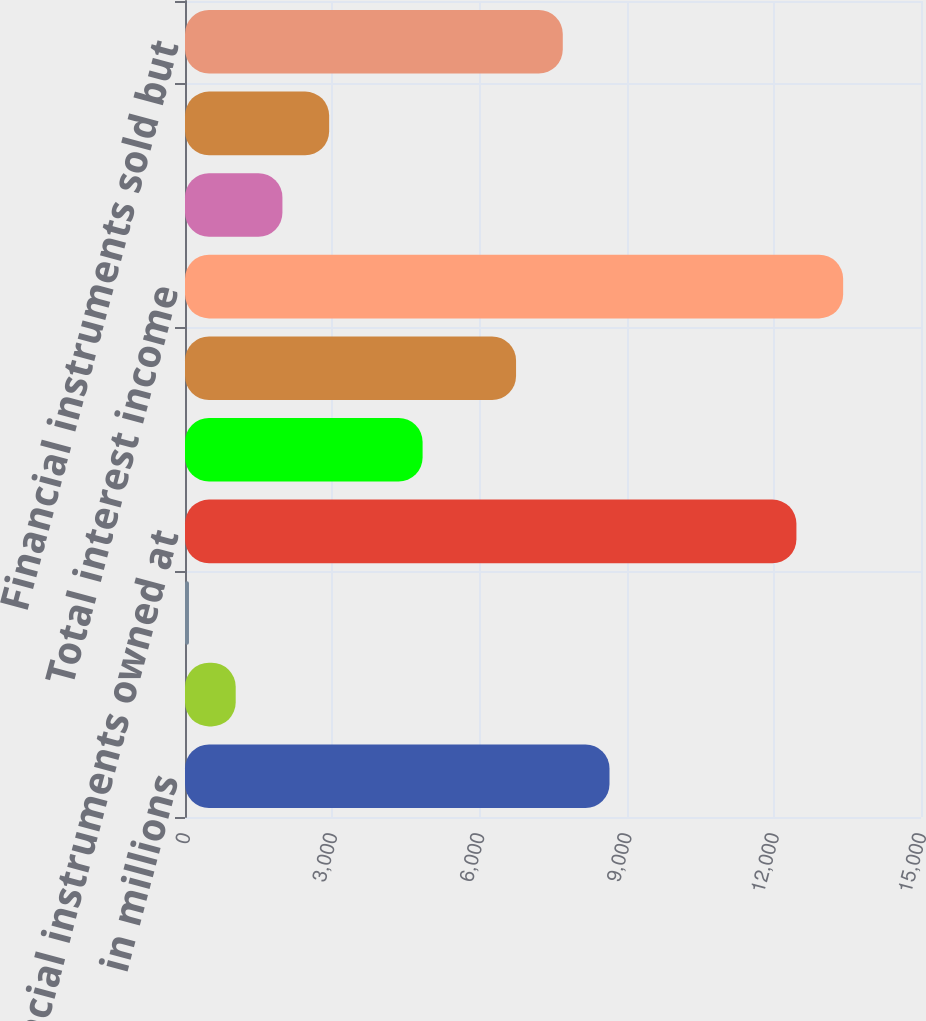Convert chart to OTSL. <chart><loc_0><loc_0><loc_500><loc_500><bar_chart><fcel>in millions<fcel>Deposits with banks<fcel>Securities borrowed securities<fcel>Financial instruments owned at<fcel>Loans receivable<fcel>Other interest 2<fcel>Total interest income<fcel>Deposits<fcel>Securities loaned and<fcel>Financial instruments sold but<nl><fcel>8651.7<fcel>1033.3<fcel>81<fcel>12460.9<fcel>4842.5<fcel>6747.1<fcel>13413.2<fcel>1985.6<fcel>2937.9<fcel>7699.4<nl></chart> 